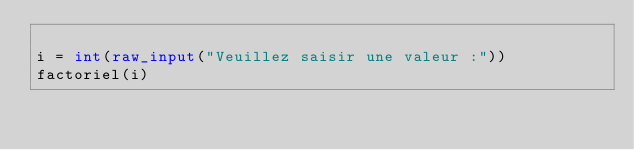<code> <loc_0><loc_0><loc_500><loc_500><_Python_>
i = int(raw_input("Veuillez saisir une valeur :"))
factoriel(i)</code> 